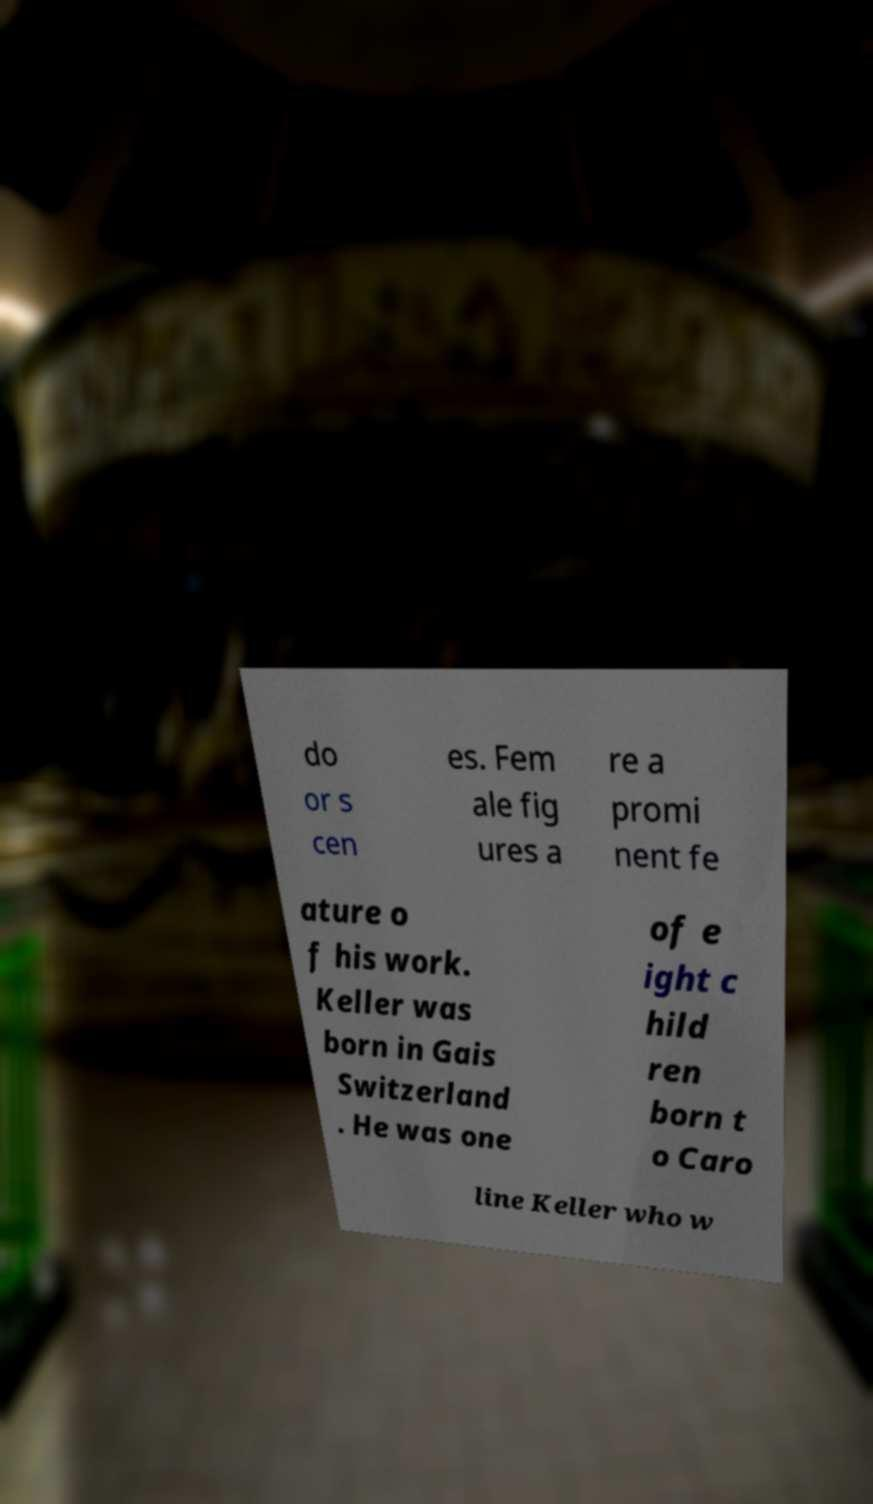What messages or text are displayed in this image? I need them in a readable, typed format. do or s cen es. Fem ale fig ures a re a promi nent fe ature o f his work. Keller was born in Gais Switzerland . He was one of e ight c hild ren born t o Caro line Keller who w 